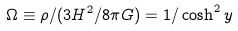<formula> <loc_0><loc_0><loc_500><loc_500>\Omega \equiv \rho / ( 3 H ^ { 2 } / 8 \pi G ) = 1 / \cosh ^ { 2 } y</formula> 